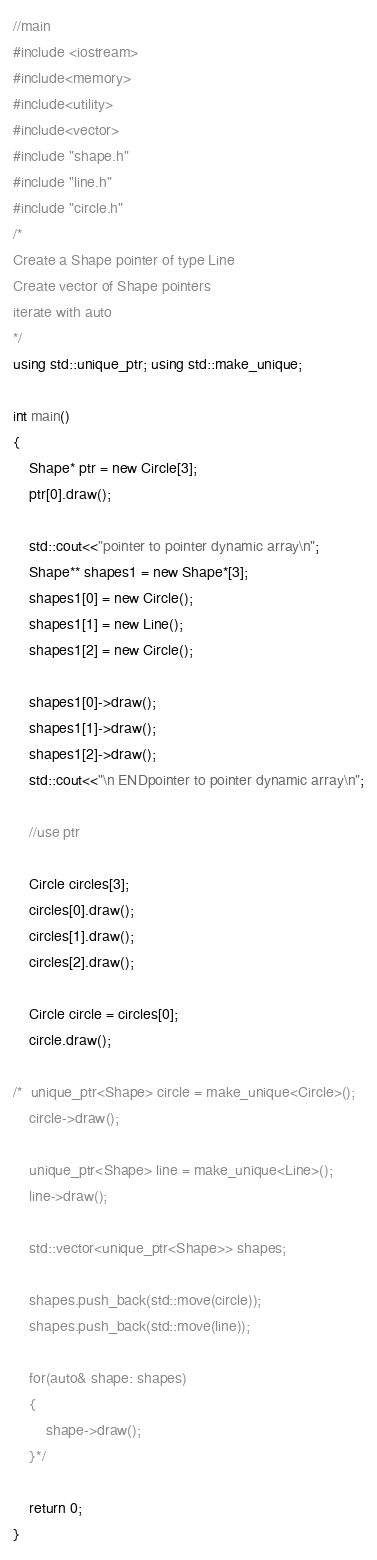Convert code to text. <code><loc_0><loc_0><loc_500><loc_500><_C++_>//main
#include <iostream>
#include<memory>
#include<utility>
#include<vector>
#include "shape.h"
#include "line.h"
#include "circle.h"
/*
Create a Shape pointer of type Line
Create vector of Shape pointers
iterate with auto
*/
using std::unique_ptr; using std::make_unique;

int main() 
{	
	Shape* ptr = new Circle[3];
	ptr[0].draw();
	
	std::cout<<"pointer to pointer dynamic array\n";
	Shape** shapes1 = new Shape*[3];
	shapes1[0] = new Circle();
	shapes1[1] = new Line();
	shapes1[2] = new Circle();

	shapes1[0]->draw();
	shapes1[1]->draw();
	shapes1[2]->draw();
	std::cout<<"\n ENDpointer to pointer dynamic array\n";

	//use ptr

	Circle circles[3];
	circles[0].draw();
	circles[1].draw();
	circles[2].draw();

	Circle circle = circles[0];
	circle.draw();

/*	unique_ptr<Shape> circle = make_unique<Circle>();
	circle->draw();

	unique_ptr<Shape> line = make_unique<Line>();
	line->draw();

	std::vector<unique_ptr<Shape>> shapes;

	shapes.push_back(std::move(circle));
	shapes.push_back(std::move(line));

	for(auto& shape: shapes)
	{
		shape->draw();
	}*/

	return 0;
}</code> 